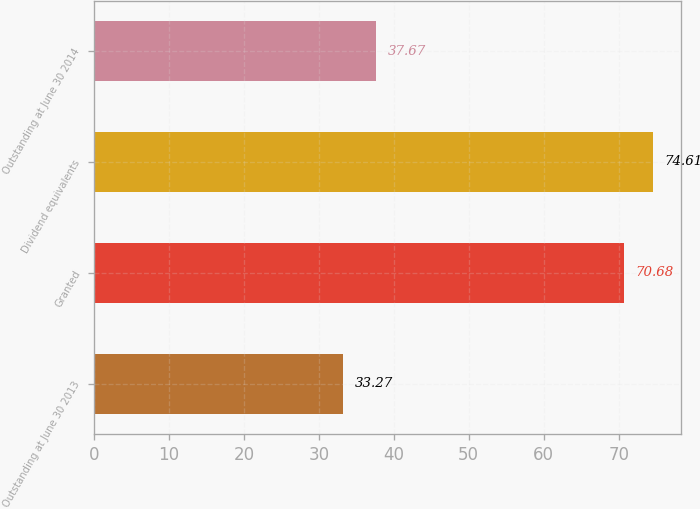<chart> <loc_0><loc_0><loc_500><loc_500><bar_chart><fcel>Outstanding at June 30 2013<fcel>Granted<fcel>Dividend equivalents<fcel>Outstanding at June 30 2014<nl><fcel>33.27<fcel>70.68<fcel>74.61<fcel>37.67<nl></chart> 